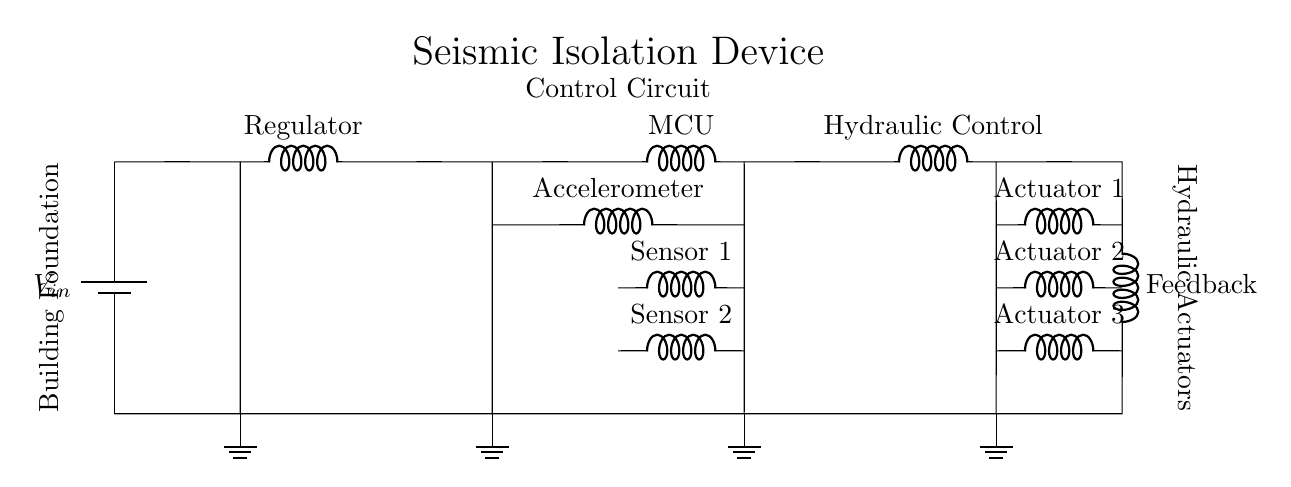What type of power supply is used? The circuit uses a battery, which is indicated by the symbol that represents a voltage source.
Answer: Battery How many sensors are present in the circuit? The diagram shows two sensor inputs labeled as Sensor 1 and Sensor 2, which indicates there are two sensors in total.
Answer: Two What component is labeled as the microcontroller? The microcontroller is represented by the component labeled "MCU" in the circuit, found after the voltage regulator and connected to the accelerometer.
Answer: MCU What is the feedback loop's role? The feedback loop connects the output of the hydraulic actuator control back to the input, allowing the system to monitor and adjust its performance based on the actuator outputs.
Answer: Performance monitoring How many hydraulic actuators are controlled by this circuit? The circuit diagram includes three outputs labeled Actuator 1, Actuator 2, and Actuator 3, indicating that there are three hydraulic actuators.
Answer: Three What is the purpose of the accelerometer in this circuit? The accelerometer measures the building's movement during seismic activity, providing data to the microcontroller for analysis to help control the hydraulic actuators effectively.
Answer: Measure movement What is the primary function of the hydraulic control component? The hydraulic control component regulates the hydraulic actuators, which adjust the building's foundation position in response to the information received from the sensors and microcontroller.
Answer: Regulate actuators 